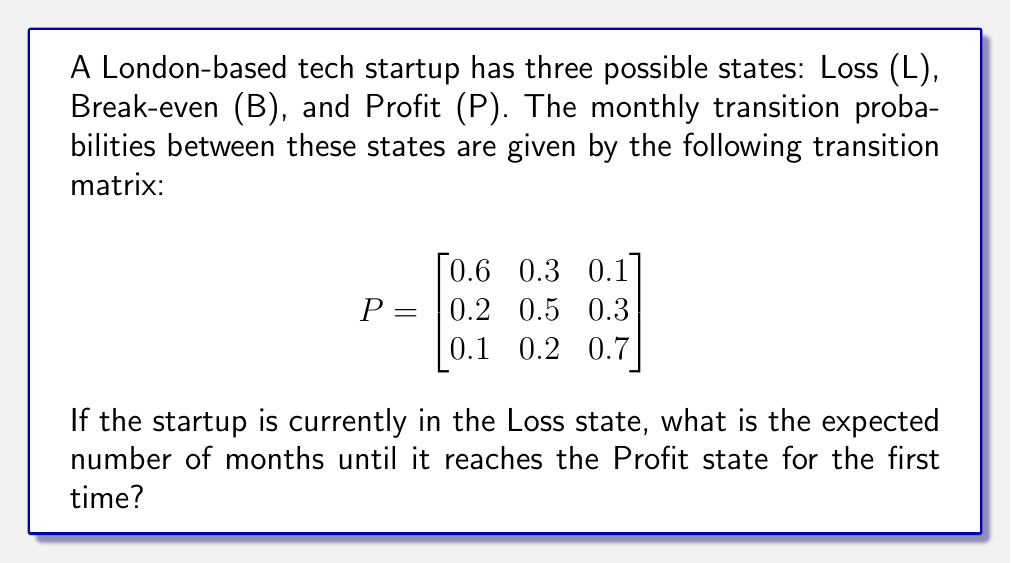Can you answer this question? To solve this problem, we'll use the concept of absorbing Markov chains and first passage times.

Step 1: Convert the problem into an absorbing Markov chain.
We'll treat the Profit state as absorbing and combine the Loss and Break-even states into transient states.

Step 2: Create the fundamental matrix.
Let $Q$ be the transition matrix for the transient states:

$$
Q = \begin{bmatrix}
0.6 & 0.3 \\
0.2 & 0.5
\end{bmatrix}
$$

The fundamental matrix $N$ is given by:

$$
N = (I - Q)^{-1}
$$

Where $I$ is the 2x2 identity matrix.

Step 3: Calculate $N$.

$$
I - Q = \begin{bmatrix}
1 & 0 \\
0 & 1
\end{bmatrix} - \begin{bmatrix}
0.6 & 0.3 \\
0.2 & 0.5
\end{bmatrix} = \begin{bmatrix}
0.4 & -0.3 \\
-0.2 & 0.5
\end{bmatrix}
$$

$$
N = (I - Q)^{-1} = \begin{bmatrix}
0.4 & -0.3 \\
-0.2 & 0.5
\end{bmatrix}^{-1} = \frac{1}{0.4 \cdot 0.5 - (-0.3) \cdot (-0.2)} \begin{bmatrix}
0.5 & 0.3 \\
0.2 & 0.4
\end{bmatrix}
$$

$$
N = \frac{1}{0.14} \begin{bmatrix}
0.5 & 0.3 \\
0.2 & 0.4
\end{bmatrix} = \begin{bmatrix}
3.57 & 2.14 \\
1.43 & 2.86
\end{bmatrix}
$$

Step 4: Calculate the expected time to absorption.
The expected number of steps starting from state $i$ until absorption is given by the $i$-th element of $N \cdot \mathbf{1}$, where $\mathbf{1}$ is a column vector of ones.

$$
N \cdot \mathbf{1} = \begin{bmatrix}
3.57 & 2.14 \\
1.43 & 2.86
\end{bmatrix} \cdot \begin{bmatrix}
1 \\
1
\end{bmatrix} = \begin{bmatrix}
5.71 \\
4.29
\end{bmatrix}
$$

Since we start in the Loss state (first row), the expected number of months until reaching the Profit state is 5.71.
Answer: 5.71 months 